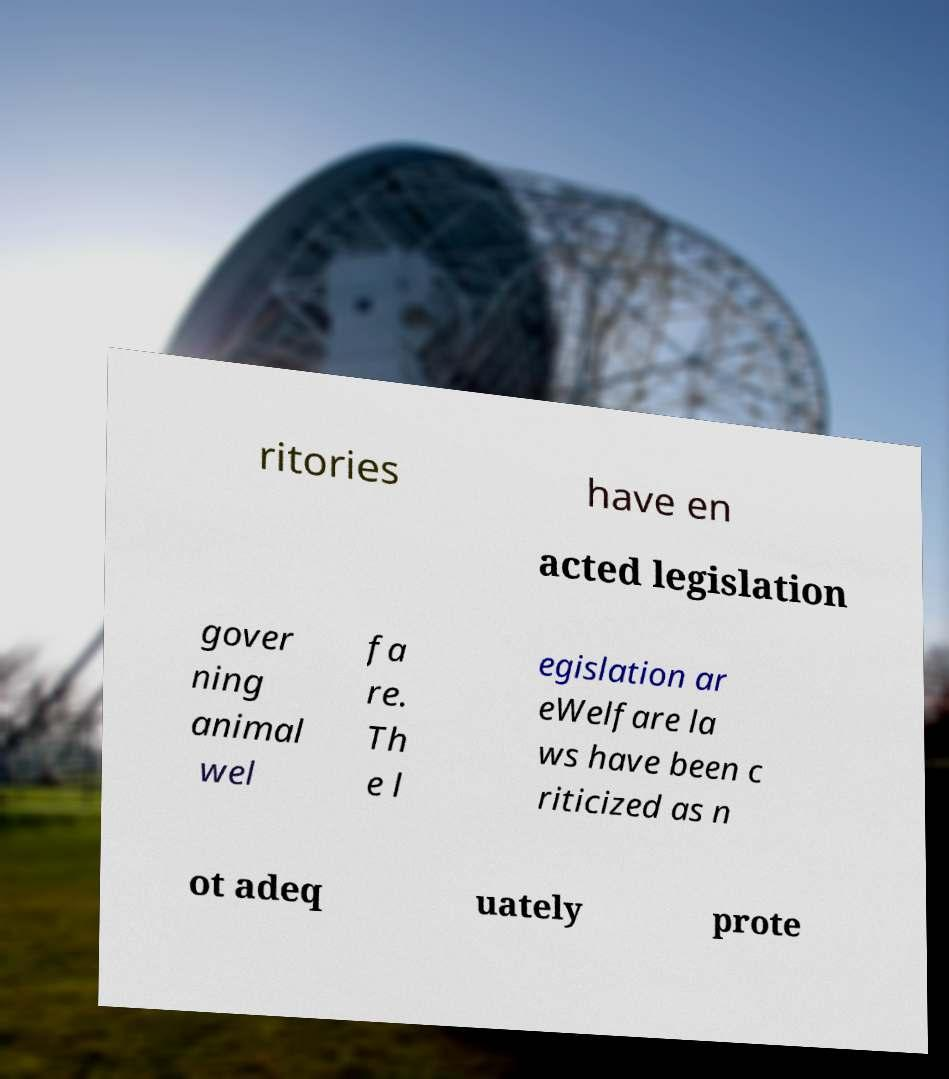Please read and relay the text visible in this image. What does it say? ritories have en acted legislation gover ning animal wel fa re. Th e l egislation ar eWelfare la ws have been c riticized as n ot adeq uately prote 